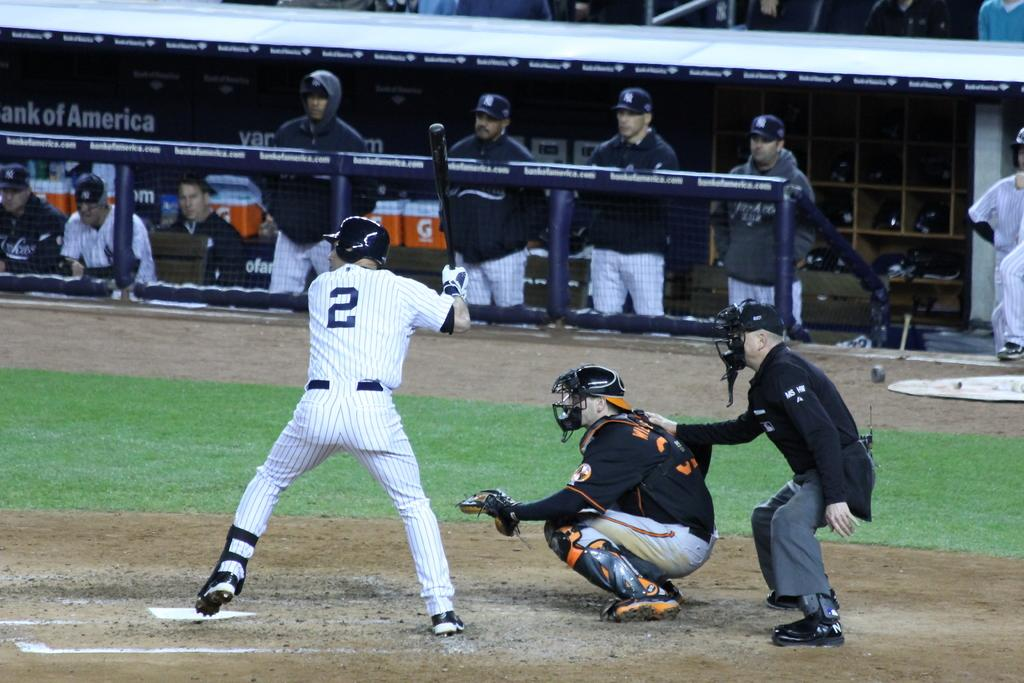<image>
Give a short and clear explanation of the subsequent image. Baseball player number 2 is getting ready to bat in a stadium that has Bank of America as a sponsor. 